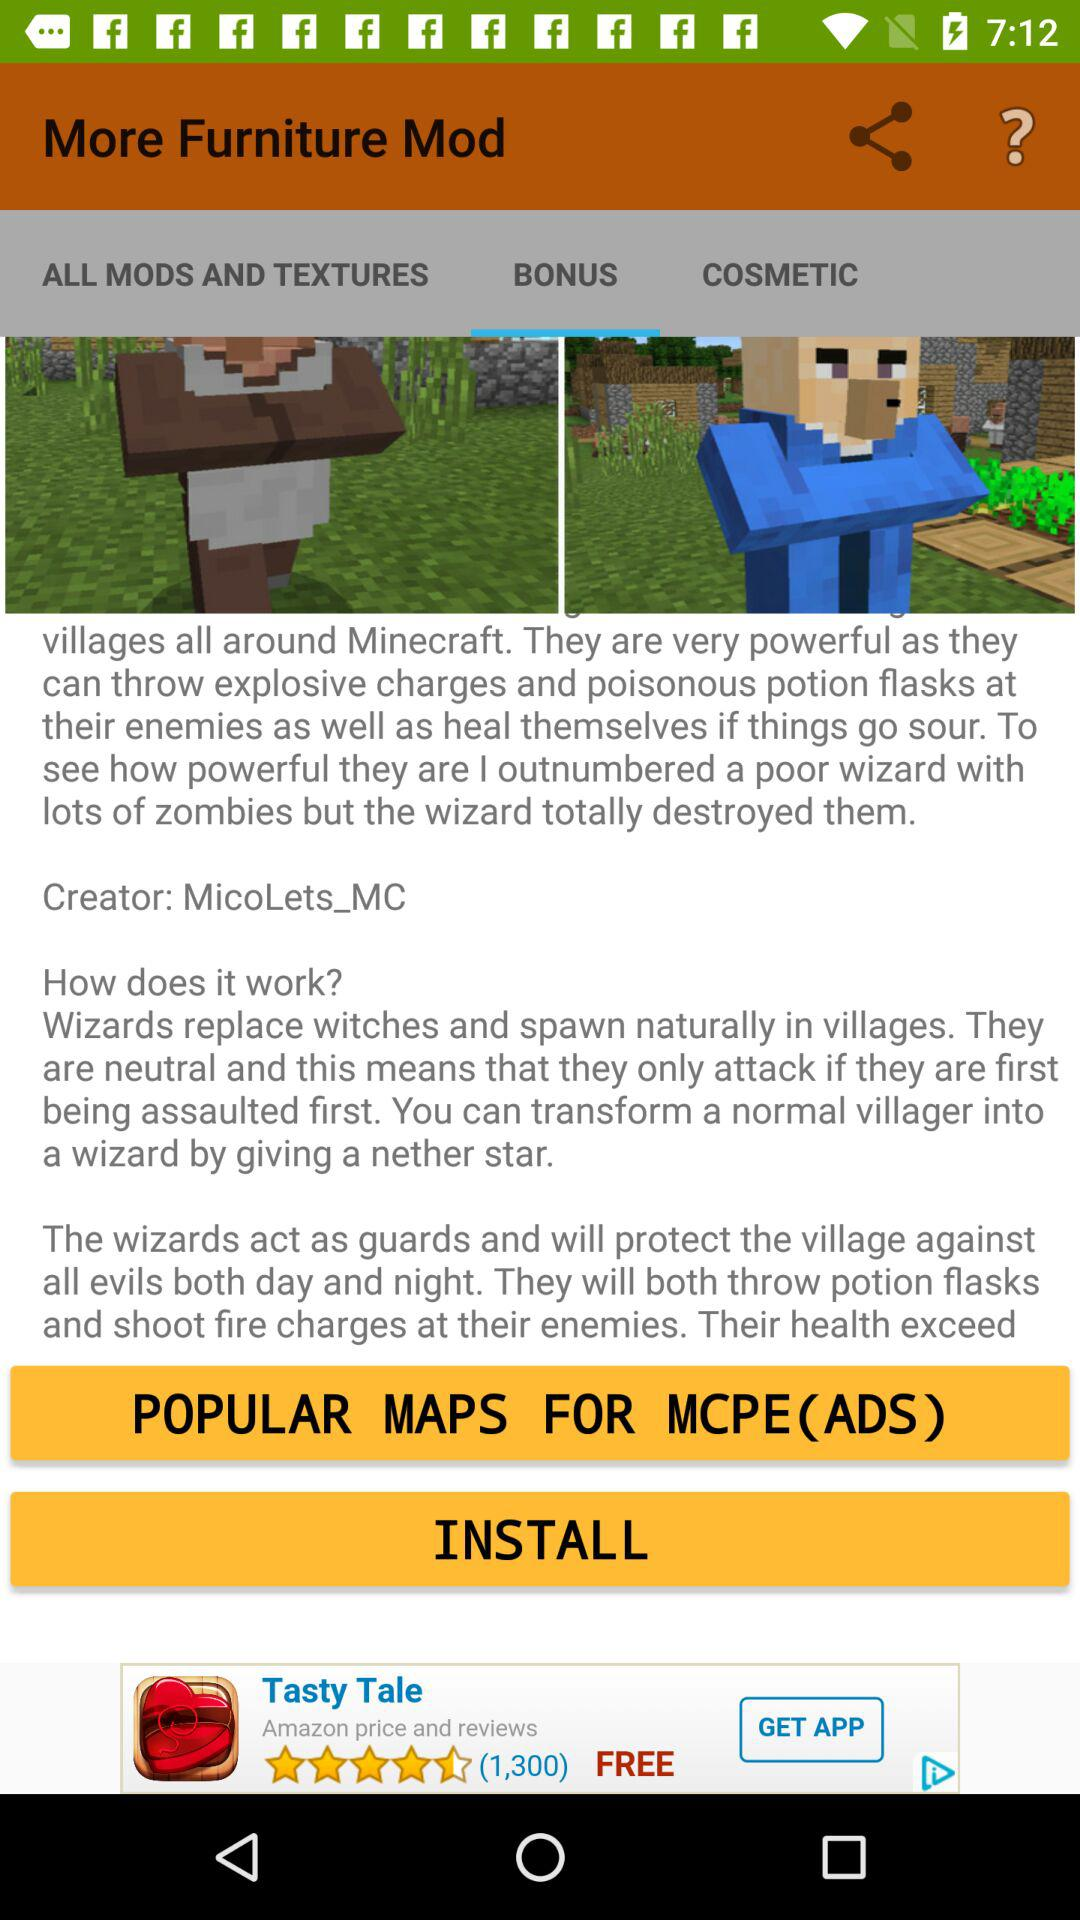Which applications are available for sharing the furniture mods?
When the provided information is insufficient, respond with <no answer>. <no answer> 